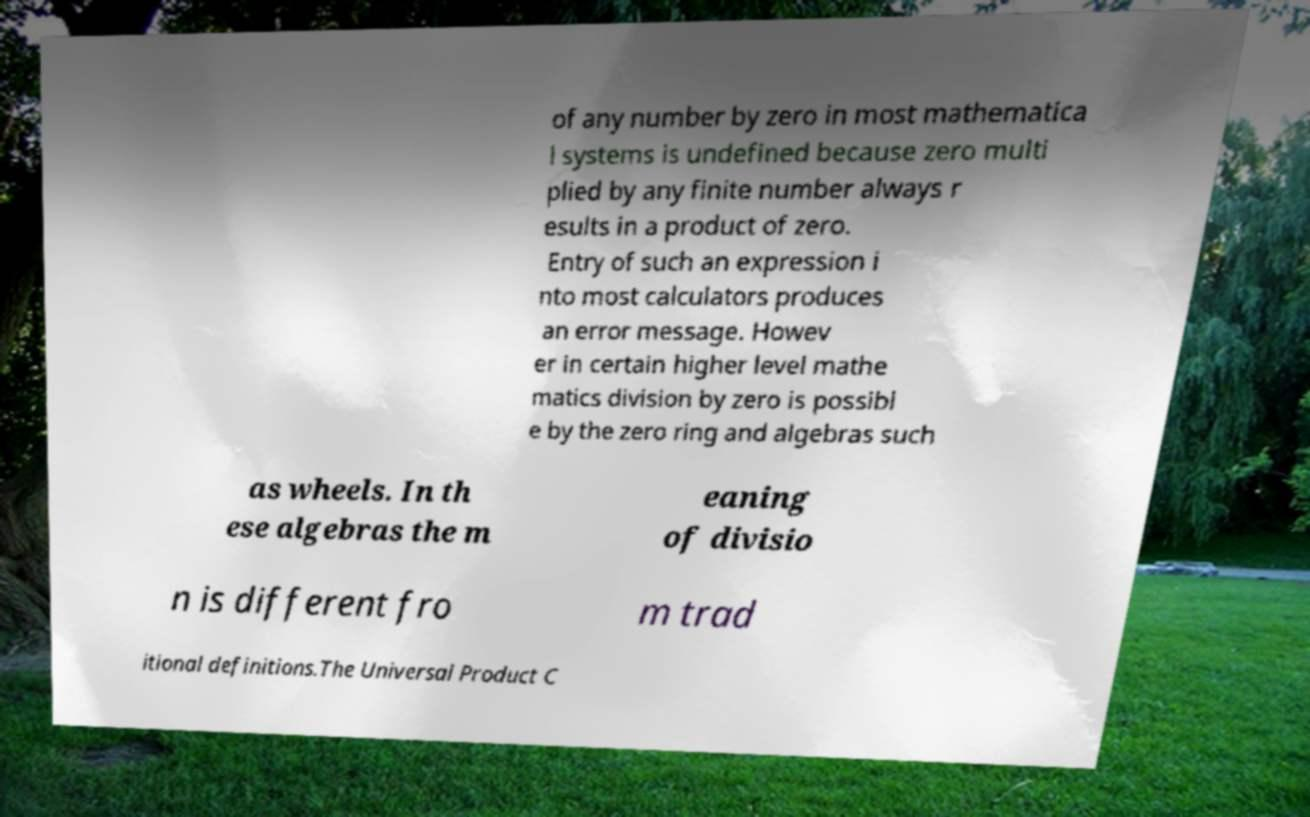Can you read and provide the text displayed in the image?This photo seems to have some interesting text. Can you extract and type it out for me? of any number by zero in most mathematica l systems is undefined because zero multi plied by any finite number always r esults in a product of zero. Entry of such an expression i nto most calculators produces an error message. Howev er in certain higher level mathe matics division by zero is possibl e by the zero ring and algebras such as wheels. In th ese algebras the m eaning of divisio n is different fro m trad itional definitions.The Universal Product C 